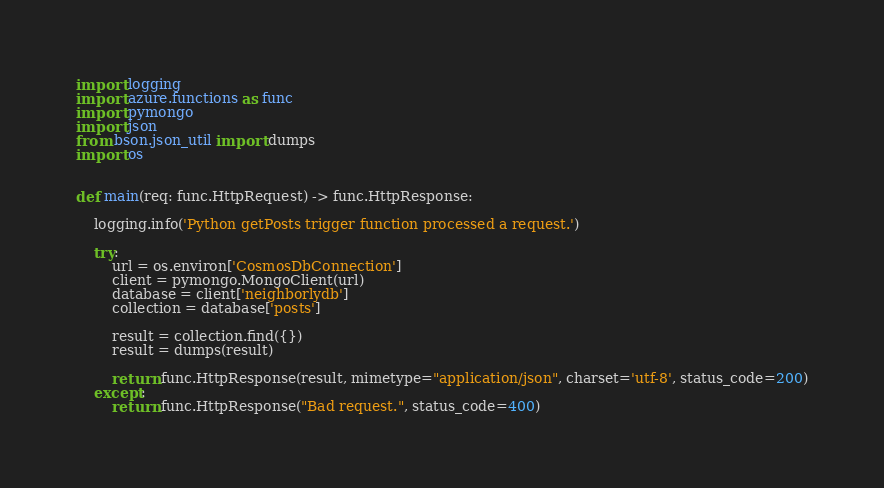<code> <loc_0><loc_0><loc_500><loc_500><_Python_>import logging
import azure.functions as func
import pymongo
import json
from bson.json_util import dumps
import os


def main(req: func.HttpRequest) -> func.HttpResponse:

    logging.info('Python getPosts trigger function processed a request.')

    try:
        url = os.environ['CosmosDbConnection']
        client = pymongo.MongoClient(url)
        database = client['neighborlydb']
        collection = database['posts']

        result = collection.find({})
        result = dumps(result)

        return func.HttpResponse(result, mimetype="application/json", charset='utf-8', status_code=200)
    except:
        return func.HttpResponse("Bad request.", status_code=400)
</code> 